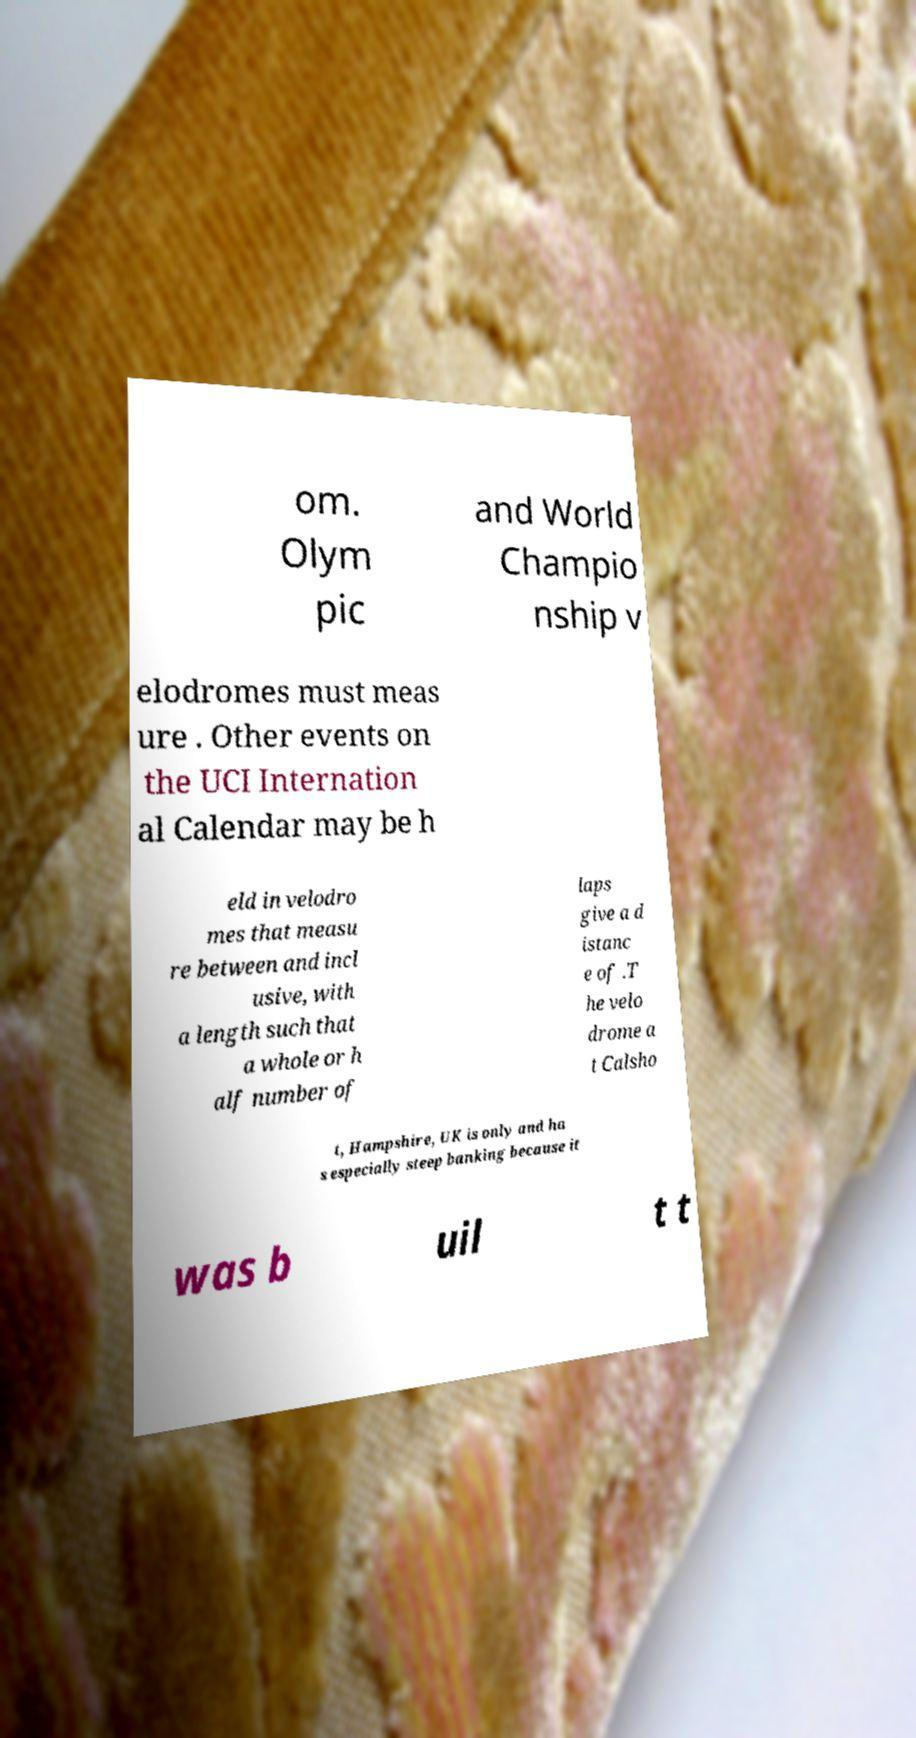Can you accurately transcribe the text from the provided image for me? om. Olym pic and World Champio nship v elodromes must meas ure . Other events on the UCI Internation al Calendar may be h eld in velodro mes that measu re between and incl usive, with a length such that a whole or h alf number of laps give a d istanc e of .T he velo drome a t Calsho t, Hampshire, UK is only and ha s especially steep banking because it was b uil t t 